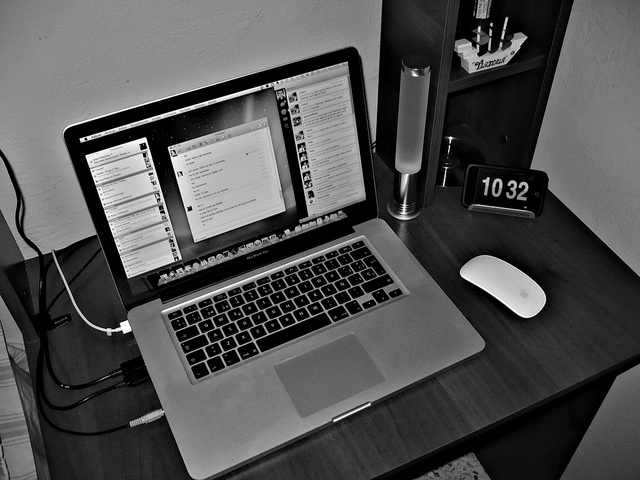<image>Which keys are the sharp ones? There are no sharp keys in the image. Which keys are the sharp ones? There are no sharp keys in the image. 